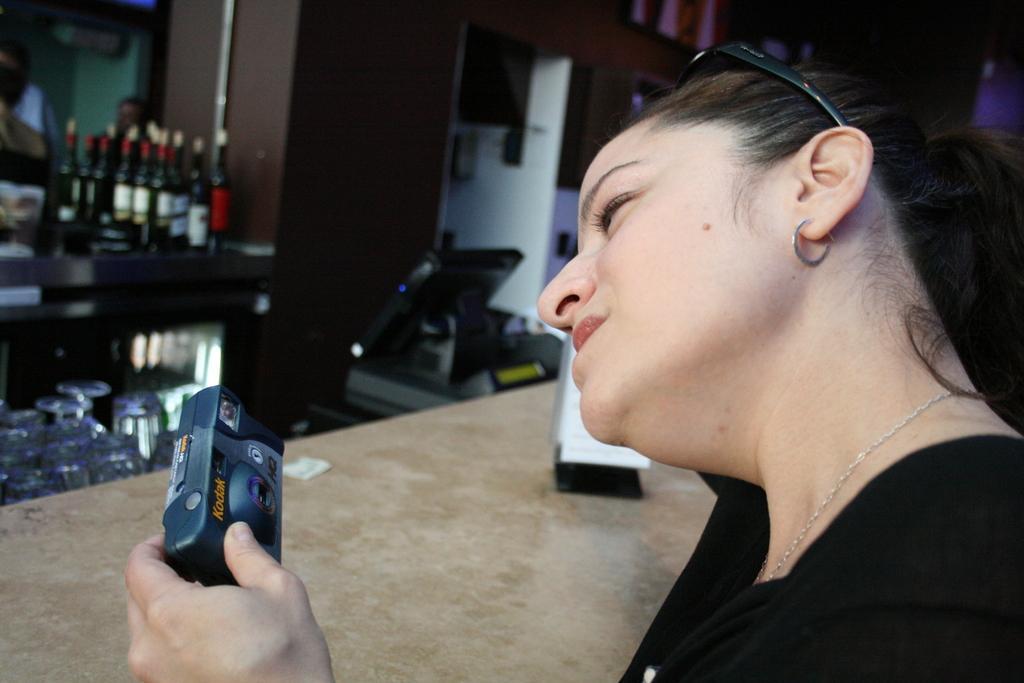Could you give a brief overview of what you see in this image? In this image I can see a person holding a camera. The person is wearing black dress, background I can see few bottles on the table and I can see cupboards in brown color. 